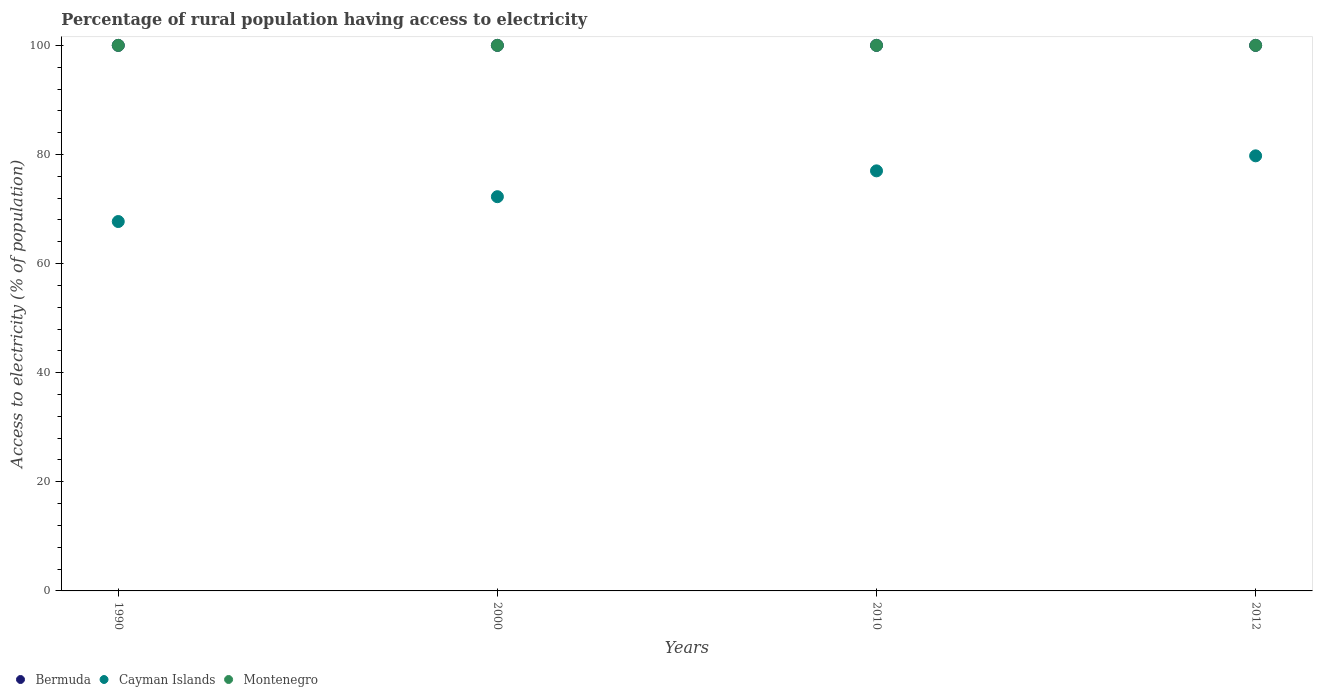How many different coloured dotlines are there?
Your answer should be compact. 3. What is the percentage of rural population having access to electricity in Montenegro in 2000?
Your answer should be compact. 100. Across all years, what is the maximum percentage of rural population having access to electricity in Cayman Islands?
Provide a succinct answer. 79.75. Across all years, what is the minimum percentage of rural population having access to electricity in Cayman Islands?
Your response must be concise. 67.71. In which year was the percentage of rural population having access to electricity in Cayman Islands maximum?
Keep it short and to the point. 2012. What is the total percentage of rural population having access to electricity in Cayman Islands in the graph?
Your response must be concise. 296.73. What is the difference between the percentage of rural population having access to electricity in Cayman Islands in 1990 and that in 2012?
Provide a succinct answer. -12.04. What is the difference between the percentage of rural population having access to electricity in Montenegro in 1990 and the percentage of rural population having access to electricity in Cayman Islands in 2010?
Offer a very short reply. 23. What is the average percentage of rural population having access to electricity in Cayman Islands per year?
Keep it short and to the point. 74.18. In the year 2012, what is the difference between the percentage of rural population having access to electricity in Cayman Islands and percentage of rural population having access to electricity in Montenegro?
Your answer should be compact. -20.25. In how many years, is the percentage of rural population having access to electricity in Montenegro greater than 20 %?
Keep it short and to the point. 4. What is the ratio of the percentage of rural population having access to electricity in Cayman Islands in 2010 to that in 2012?
Your answer should be compact. 0.97. What is the difference between the highest and the second highest percentage of rural population having access to electricity in Cayman Islands?
Offer a very short reply. 2.75. What is the difference between the highest and the lowest percentage of rural population having access to electricity in Bermuda?
Keep it short and to the point. 0. Is it the case that in every year, the sum of the percentage of rural population having access to electricity in Bermuda and percentage of rural population having access to electricity in Cayman Islands  is greater than the percentage of rural population having access to electricity in Montenegro?
Make the answer very short. Yes. Does the percentage of rural population having access to electricity in Cayman Islands monotonically increase over the years?
Offer a very short reply. Yes. Is the percentage of rural population having access to electricity in Cayman Islands strictly greater than the percentage of rural population having access to electricity in Bermuda over the years?
Give a very brief answer. No. What is the difference between two consecutive major ticks on the Y-axis?
Keep it short and to the point. 20. Does the graph contain any zero values?
Your response must be concise. No. Does the graph contain grids?
Offer a very short reply. No. Where does the legend appear in the graph?
Provide a succinct answer. Bottom left. How many legend labels are there?
Ensure brevity in your answer.  3. What is the title of the graph?
Offer a terse response. Percentage of rural population having access to electricity. Does "Peru" appear as one of the legend labels in the graph?
Ensure brevity in your answer.  No. What is the label or title of the X-axis?
Ensure brevity in your answer.  Years. What is the label or title of the Y-axis?
Give a very brief answer. Access to electricity (% of population). What is the Access to electricity (% of population) of Bermuda in 1990?
Give a very brief answer. 100. What is the Access to electricity (% of population) of Cayman Islands in 1990?
Give a very brief answer. 67.71. What is the Access to electricity (% of population) in Montenegro in 1990?
Your response must be concise. 100. What is the Access to electricity (% of population) in Cayman Islands in 2000?
Keep it short and to the point. 72.27. What is the Access to electricity (% of population) of Montenegro in 2000?
Provide a succinct answer. 100. What is the Access to electricity (% of population) of Montenegro in 2010?
Your answer should be very brief. 100. What is the Access to electricity (% of population) in Cayman Islands in 2012?
Your answer should be very brief. 79.75. What is the Access to electricity (% of population) in Montenegro in 2012?
Your answer should be compact. 100. Across all years, what is the maximum Access to electricity (% of population) of Bermuda?
Give a very brief answer. 100. Across all years, what is the maximum Access to electricity (% of population) of Cayman Islands?
Make the answer very short. 79.75. Across all years, what is the minimum Access to electricity (% of population) in Bermuda?
Your answer should be compact. 100. Across all years, what is the minimum Access to electricity (% of population) of Cayman Islands?
Your answer should be very brief. 67.71. What is the total Access to electricity (% of population) of Bermuda in the graph?
Make the answer very short. 400. What is the total Access to electricity (% of population) of Cayman Islands in the graph?
Ensure brevity in your answer.  296.73. What is the total Access to electricity (% of population) of Montenegro in the graph?
Provide a short and direct response. 400. What is the difference between the Access to electricity (% of population) in Bermuda in 1990 and that in 2000?
Offer a very short reply. 0. What is the difference between the Access to electricity (% of population) of Cayman Islands in 1990 and that in 2000?
Provide a short and direct response. -4.55. What is the difference between the Access to electricity (% of population) of Bermuda in 1990 and that in 2010?
Your response must be concise. 0. What is the difference between the Access to electricity (% of population) of Cayman Islands in 1990 and that in 2010?
Give a very brief answer. -9.29. What is the difference between the Access to electricity (% of population) in Montenegro in 1990 and that in 2010?
Offer a terse response. 0. What is the difference between the Access to electricity (% of population) of Cayman Islands in 1990 and that in 2012?
Provide a succinct answer. -12.04. What is the difference between the Access to electricity (% of population) of Montenegro in 1990 and that in 2012?
Your response must be concise. 0. What is the difference between the Access to electricity (% of population) of Bermuda in 2000 and that in 2010?
Your response must be concise. 0. What is the difference between the Access to electricity (% of population) of Cayman Islands in 2000 and that in 2010?
Keep it short and to the point. -4.74. What is the difference between the Access to electricity (% of population) in Montenegro in 2000 and that in 2010?
Make the answer very short. 0. What is the difference between the Access to electricity (% of population) of Bermuda in 2000 and that in 2012?
Your answer should be compact. 0. What is the difference between the Access to electricity (% of population) in Cayman Islands in 2000 and that in 2012?
Offer a terse response. -7.49. What is the difference between the Access to electricity (% of population) in Bermuda in 2010 and that in 2012?
Provide a short and direct response. 0. What is the difference between the Access to electricity (% of population) in Cayman Islands in 2010 and that in 2012?
Offer a terse response. -2.75. What is the difference between the Access to electricity (% of population) of Montenegro in 2010 and that in 2012?
Offer a very short reply. 0. What is the difference between the Access to electricity (% of population) in Bermuda in 1990 and the Access to electricity (% of population) in Cayman Islands in 2000?
Offer a very short reply. 27.73. What is the difference between the Access to electricity (% of population) in Bermuda in 1990 and the Access to electricity (% of population) in Montenegro in 2000?
Provide a short and direct response. 0. What is the difference between the Access to electricity (% of population) in Cayman Islands in 1990 and the Access to electricity (% of population) in Montenegro in 2000?
Your response must be concise. -32.29. What is the difference between the Access to electricity (% of population) in Bermuda in 1990 and the Access to electricity (% of population) in Cayman Islands in 2010?
Ensure brevity in your answer.  23. What is the difference between the Access to electricity (% of population) in Bermuda in 1990 and the Access to electricity (% of population) in Montenegro in 2010?
Ensure brevity in your answer.  0. What is the difference between the Access to electricity (% of population) in Cayman Islands in 1990 and the Access to electricity (% of population) in Montenegro in 2010?
Offer a terse response. -32.29. What is the difference between the Access to electricity (% of population) in Bermuda in 1990 and the Access to electricity (% of population) in Cayman Islands in 2012?
Provide a short and direct response. 20.25. What is the difference between the Access to electricity (% of population) in Cayman Islands in 1990 and the Access to electricity (% of population) in Montenegro in 2012?
Provide a short and direct response. -32.29. What is the difference between the Access to electricity (% of population) of Bermuda in 2000 and the Access to electricity (% of population) of Cayman Islands in 2010?
Your answer should be compact. 23. What is the difference between the Access to electricity (% of population) in Cayman Islands in 2000 and the Access to electricity (% of population) in Montenegro in 2010?
Make the answer very short. -27.73. What is the difference between the Access to electricity (% of population) of Bermuda in 2000 and the Access to electricity (% of population) of Cayman Islands in 2012?
Offer a terse response. 20.25. What is the difference between the Access to electricity (% of population) of Cayman Islands in 2000 and the Access to electricity (% of population) of Montenegro in 2012?
Keep it short and to the point. -27.73. What is the difference between the Access to electricity (% of population) in Bermuda in 2010 and the Access to electricity (% of population) in Cayman Islands in 2012?
Your answer should be very brief. 20.25. What is the average Access to electricity (% of population) in Bermuda per year?
Provide a succinct answer. 100. What is the average Access to electricity (% of population) in Cayman Islands per year?
Your answer should be very brief. 74.18. What is the average Access to electricity (% of population) of Montenegro per year?
Your answer should be compact. 100. In the year 1990, what is the difference between the Access to electricity (% of population) of Bermuda and Access to electricity (% of population) of Cayman Islands?
Provide a short and direct response. 32.29. In the year 1990, what is the difference between the Access to electricity (% of population) of Bermuda and Access to electricity (% of population) of Montenegro?
Give a very brief answer. 0. In the year 1990, what is the difference between the Access to electricity (% of population) in Cayman Islands and Access to electricity (% of population) in Montenegro?
Your answer should be very brief. -32.29. In the year 2000, what is the difference between the Access to electricity (% of population) of Bermuda and Access to electricity (% of population) of Cayman Islands?
Make the answer very short. 27.73. In the year 2000, what is the difference between the Access to electricity (% of population) of Cayman Islands and Access to electricity (% of population) of Montenegro?
Provide a succinct answer. -27.73. In the year 2010, what is the difference between the Access to electricity (% of population) in Bermuda and Access to electricity (% of population) in Cayman Islands?
Provide a short and direct response. 23. In the year 2012, what is the difference between the Access to electricity (% of population) in Bermuda and Access to electricity (% of population) in Cayman Islands?
Ensure brevity in your answer.  20.25. In the year 2012, what is the difference between the Access to electricity (% of population) in Bermuda and Access to electricity (% of population) in Montenegro?
Make the answer very short. 0. In the year 2012, what is the difference between the Access to electricity (% of population) of Cayman Islands and Access to electricity (% of population) of Montenegro?
Give a very brief answer. -20.25. What is the ratio of the Access to electricity (% of population) in Cayman Islands in 1990 to that in 2000?
Keep it short and to the point. 0.94. What is the ratio of the Access to electricity (% of population) of Cayman Islands in 1990 to that in 2010?
Your answer should be compact. 0.88. What is the ratio of the Access to electricity (% of population) of Bermuda in 1990 to that in 2012?
Offer a very short reply. 1. What is the ratio of the Access to electricity (% of population) of Cayman Islands in 1990 to that in 2012?
Offer a very short reply. 0.85. What is the ratio of the Access to electricity (% of population) of Montenegro in 1990 to that in 2012?
Make the answer very short. 1. What is the ratio of the Access to electricity (% of population) of Cayman Islands in 2000 to that in 2010?
Provide a short and direct response. 0.94. What is the ratio of the Access to electricity (% of population) in Bermuda in 2000 to that in 2012?
Your response must be concise. 1. What is the ratio of the Access to electricity (% of population) of Cayman Islands in 2000 to that in 2012?
Keep it short and to the point. 0.91. What is the ratio of the Access to electricity (% of population) in Bermuda in 2010 to that in 2012?
Provide a short and direct response. 1. What is the ratio of the Access to electricity (% of population) in Cayman Islands in 2010 to that in 2012?
Provide a succinct answer. 0.97. What is the difference between the highest and the second highest Access to electricity (% of population) of Cayman Islands?
Make the answer very short. 2.75. What is the difference between the highest and the second highest Access to electricity (% of population) in Montenegro?
Give a very brief answer. 0. What is the difference between the highest and the lowest Access to electricity (% of population) in Bermuda?
Make the answer very short. 0. What is the difference between the highest and the lowest Access to electricity (% of population) in Cayman Islands?
Your answer should be very brief. 12.04. 